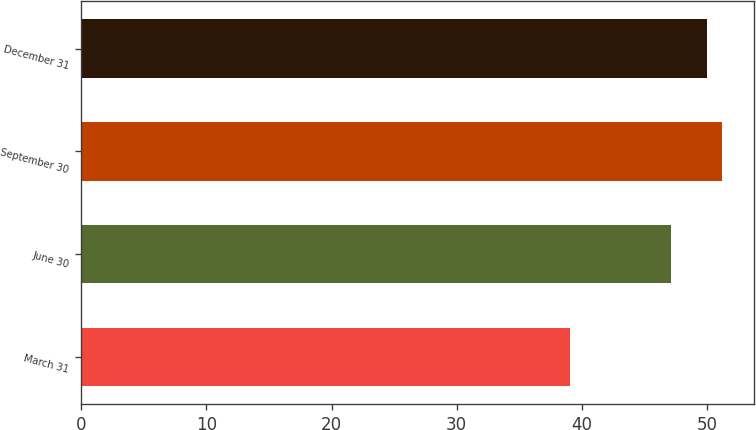Convert chart. <chart><loc_0><loc_0><loc_500><loc_500><bar_chart><fcel>March 31<fcel>June 30<fcel>September 30<fcel>December 31<nl><fcel>39.03<fcel>47.14<fcel>51.19<fcel>50<nl></chart> 